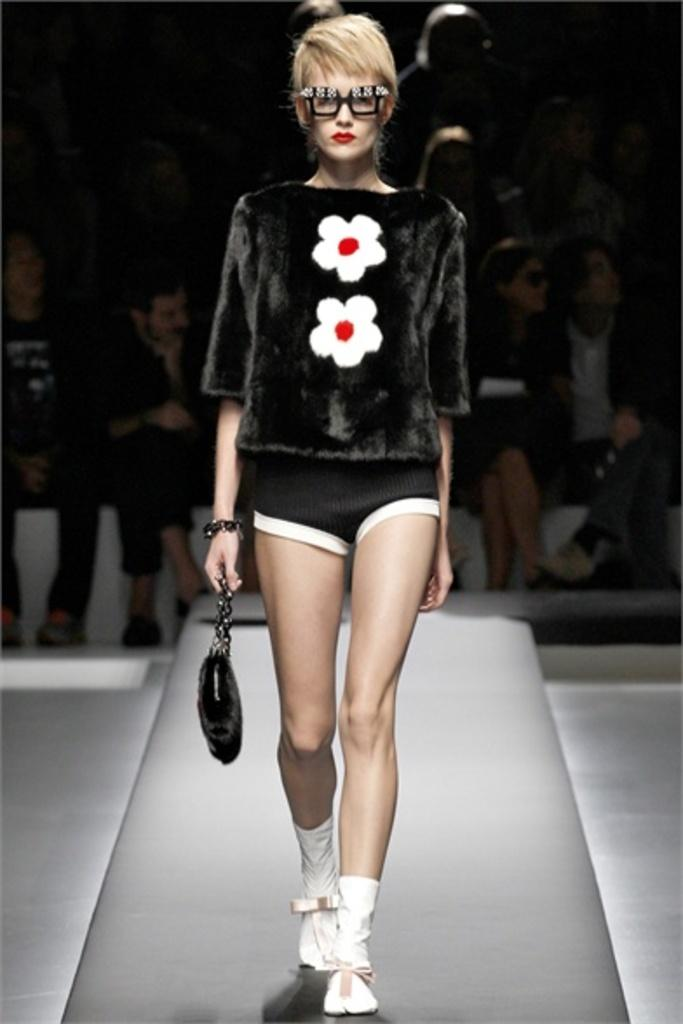Who is the main subject in the foreground of the image? There is a woman in the foreground of the image. What is the woman holding in her hand? The woman is holding a bag in her hand. Where does the scene take place? The scene takes place on a stage. When was the image taken? The image was taken during nighttime. What can be seen in the background of the image? There is a crowd in the background of the image. What type of army is present in the image? There is no army present in the image. How old is the girl in the image? There is no girl present in the image; it features a woman. What month is the image taken in? The month is not mentioned in the provided facts, so it cannot be determined from the image. 